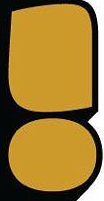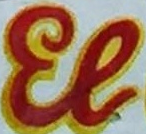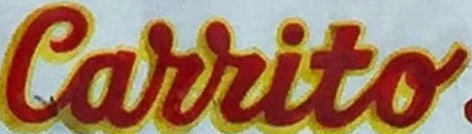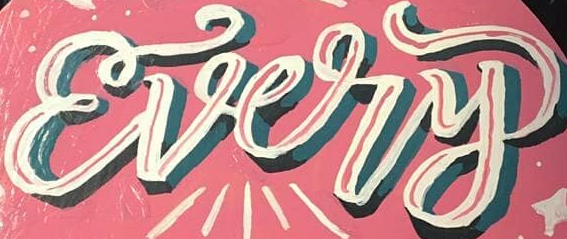What words can you see in these images in sequence, separated by a semicolon? !; El; Carrito; Every 